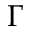<formula> <loc_0><loc_0><loc_500><loc_500>\Gamma</formula> 